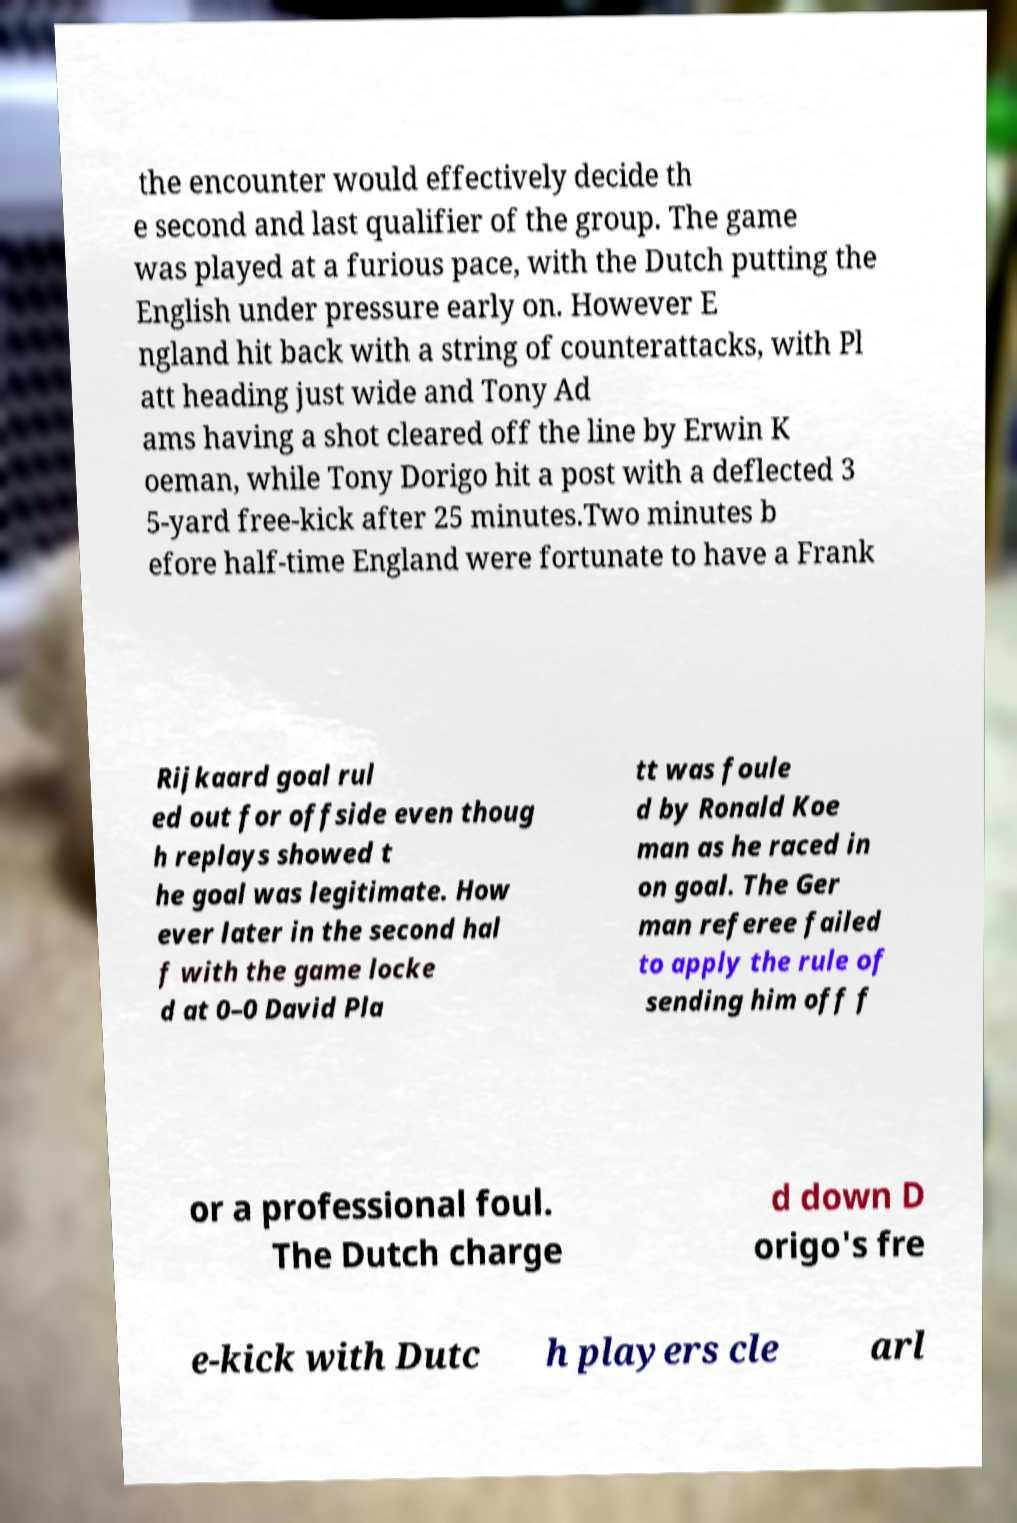For documentation purposes, I need the text within this image transcribed. Could you provide that? the encounter would effectively decide th e second and last qualifier of the group. The game was played at a furious pace, with the Dutch putting the English under pressure early on. However E ngland hit back with a string of counterattacks, with Pl att heading just wide and Tony Ad ams having a shot cleared off the line by Erwin K oeman, while Tony Dorigo hit a post with a deflected 3 5-yard free-kick after 25 minutes.Two minutes b efore half-time England were fortunate to have a Frank Rijkaard goal rul ed out for offside even thoug h replays showed t he goal was legitimate. How ever later in the second hal f with the game locke d at 0–0 David Pla tt was foule d by Ronald Koe man as he raced in on goal. The Ger man referee failed to apply the rule of sending him off f or a professional foul. The Dutch charge d down D origo's fre e-kick with Dutc h players cle arl 